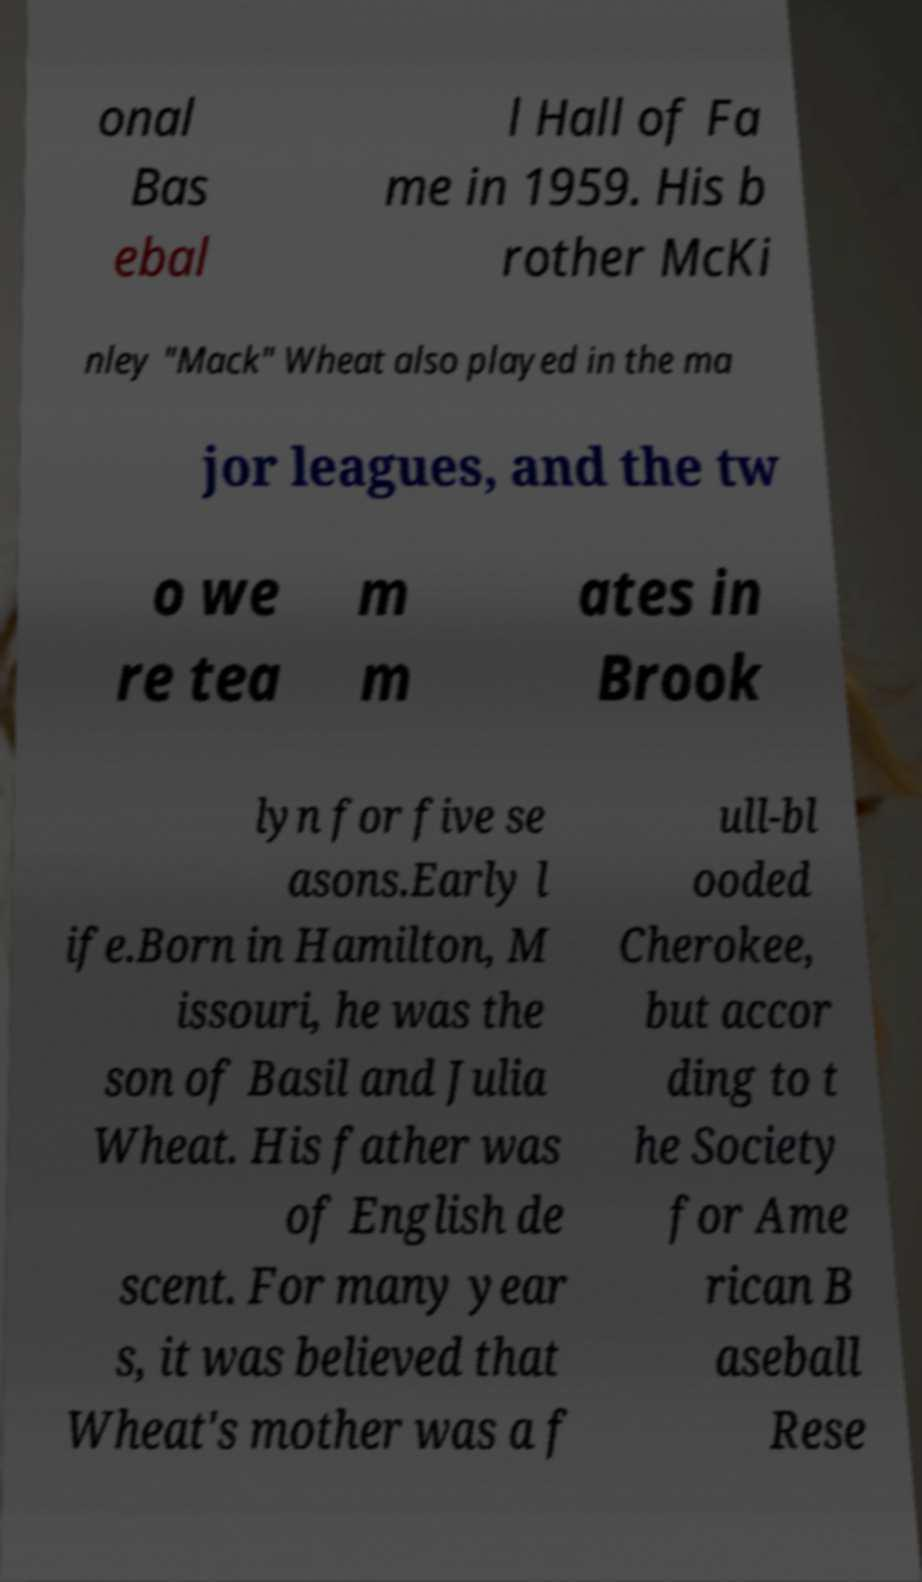Please identify and transcribe the text found in this image. onal Bas ebal l Hall of Fa me in 1959. His b rother McKi nley "Mack" Wheat also played in the ma jor leagues, and the tw o we re tea m m ates in Brook lyn for five se asons.Early l ife.Born in Hamilton, M issouri, he was the son of Basil and Julia Wheat. His father was of English de scent. For many year s, it was believed that Wheat's mother was a f ull-bl ooded Cherokee, but accor ding to t he Society for Ame rican B aseball Rese 